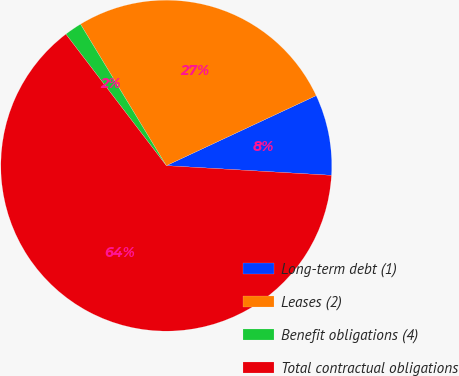Convert chart. <chart><loc_0><loc_0><loc_500><loc_500><pie_chart><fcel>Long-term debt (1)<fcel>Leases (2)<fcel>Benefit obligations (4)<fcel>Total contractual obligations<nl><fcel>7.89%<fcel>26.72%<fcel>1.7%<fcel>63.69%<nl></chart> 